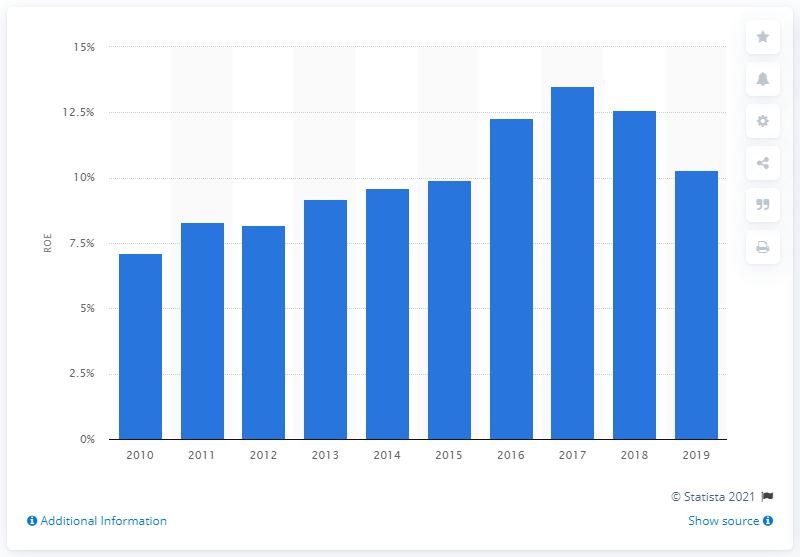Point out several critical features in this image. The return on equity peaked at 13.5% in 2017. The return on equity (ROE) of the alcoholic and non-alcoholic beverage industry in 2019 was 10.3%. 